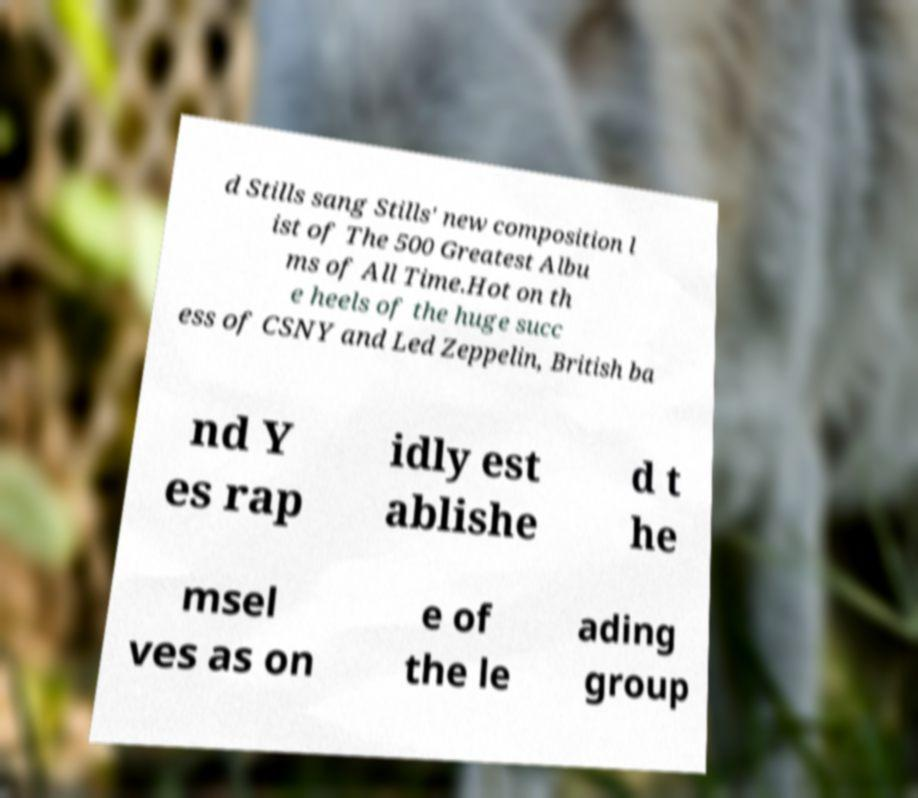For documentation purposes, I need the text within this image transcribed. Could you provide that? d Stills sang Stills' new composition l ist of The 500 Greatest Albu ms of All Time.Hot on th e heels of the huge succ ess of CSNY and Led Zeppelin, British ba nd Y es rap idly est ablishe d t he msel ves as on e of the le ading group 